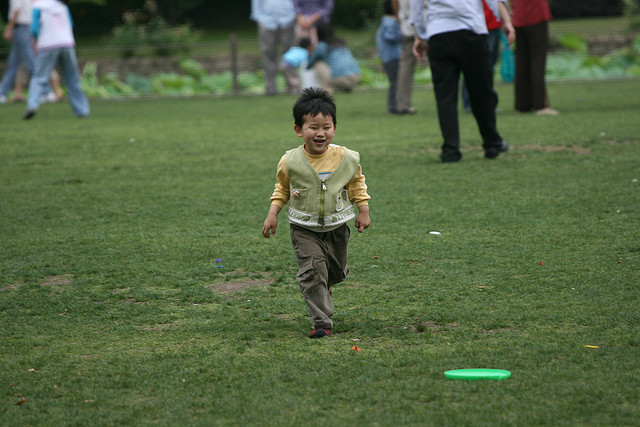How many children are there? Based on the image, there is one child visible, who appears to be joyfully running across a grassy area. 